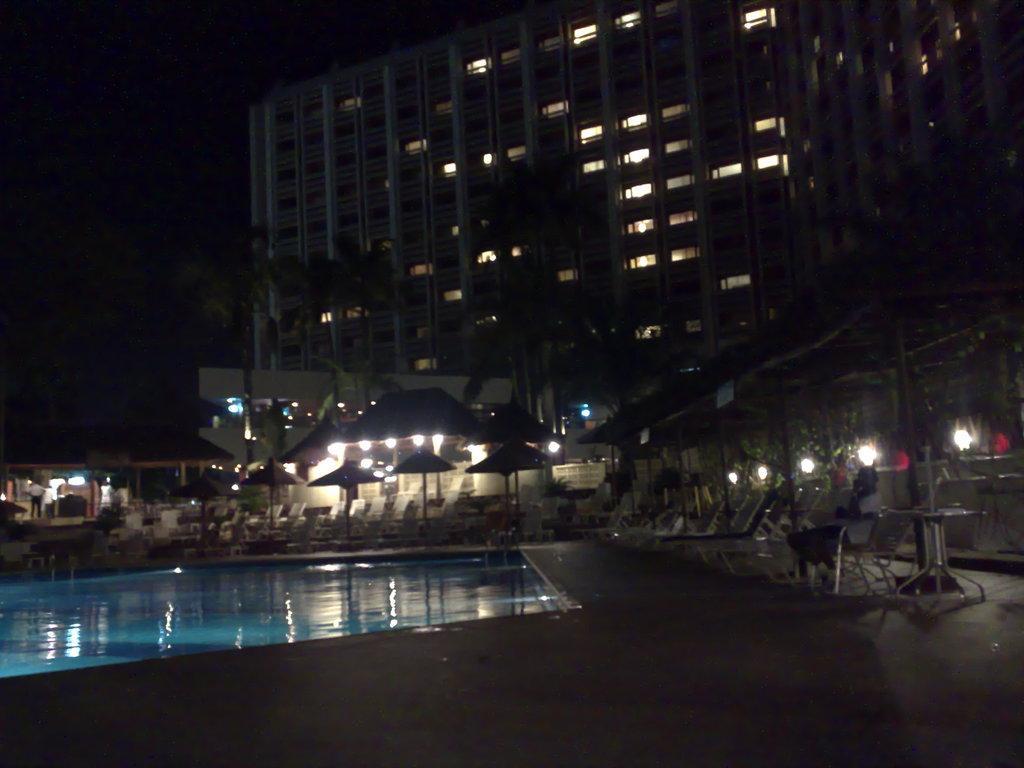Describe this image in one or two sentences. In this image we can see buildings, trees, parasols, chaise lounges, person sitting on the chair, side tables, electric lights, swimming pool and sky. 